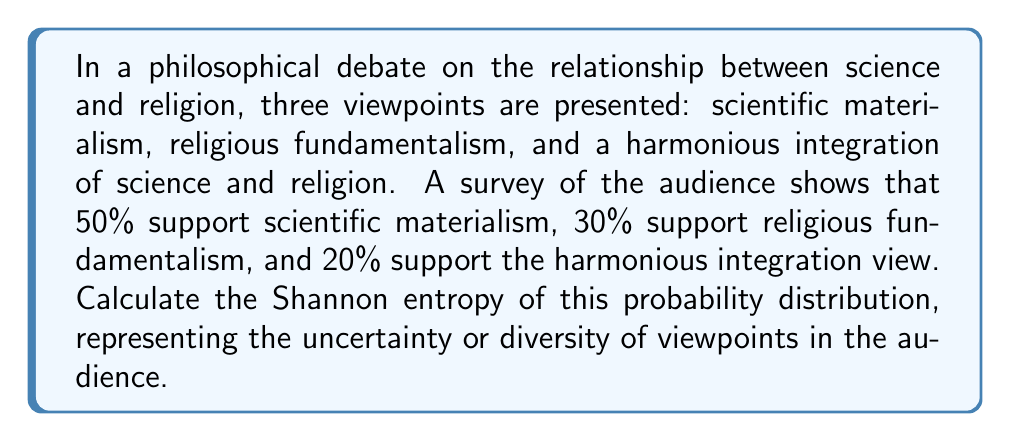Could you help me with this problem? To calculate the Shannon entropy of this probability distribution, we'll use the formula:

$$H = -\sum_{i=1}^n p_i \log_2(p_i)$$

Where:
- $H$ is the Shannon entropy
- $p_i$ is the probability of each outcome
- $n$ is the number of possible outcomes

Let's break it down step-by-step:

1) We have three probabilities:
   $p_1 = 0.50$ (scientific materialism)
   $p_2 = 0.30$ (religious fundamentalism)
   $p_3 = 0.20$ (harmonious integration)

2) Now, let's calculate each term of the sum:

   For $p_1$: $-0.50 \log_2(0.50) = 0.50$
   For $p_2$: $-0.30 \log_2(0.30) \approx 0.521$
   For $p_3$: $-0.20 \log_2(0.20) \approx 0.464$

3) Sum these values:

   $H = 0.50 + 0.521 + 0.464 = 1.485$

The Shannon entropy is approximately 1.485 bits. This value represents the average amount of information contained in each event or the uncertainty in the probability distribution. A higher value indicates more uncertainty or diversity in the viewpoints.
Answer: $H \approx 1.485$ bits 